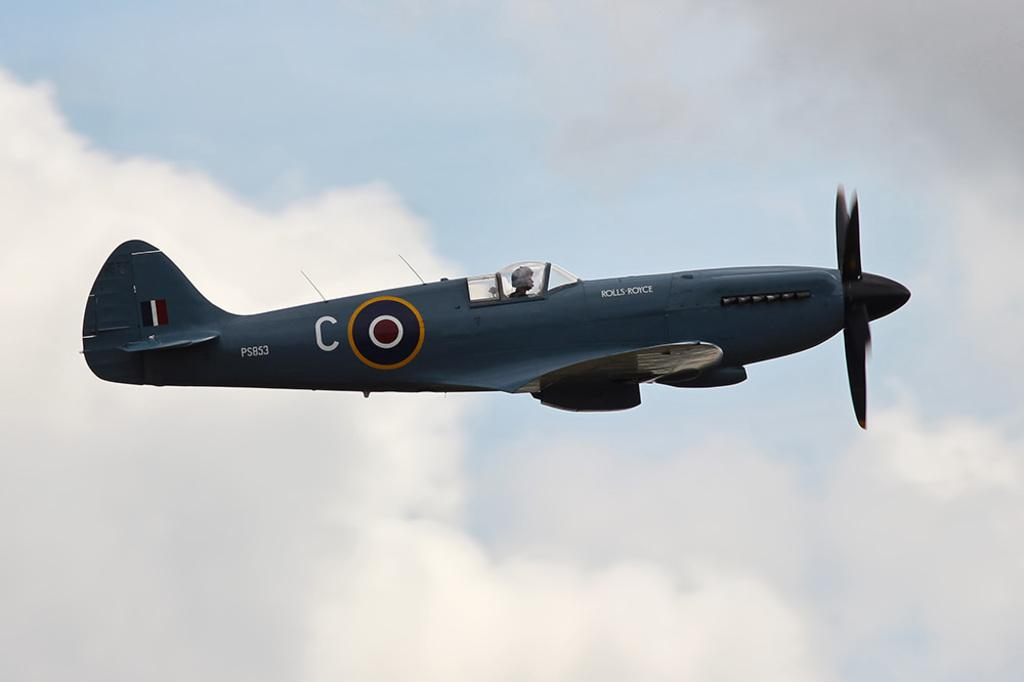<image>
Offer a succinct explanation of the picture presented. A Rolls Royce army jet sours the cloudy blue skys 